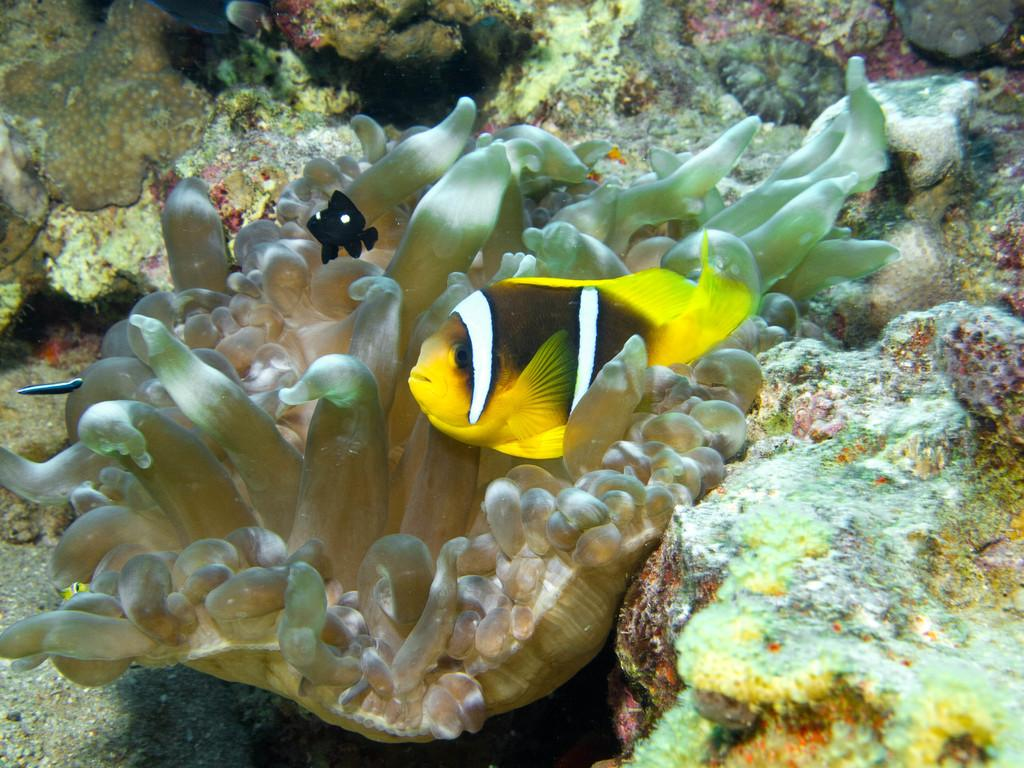What type of animal is in the image? There is a fish in the image. What color is the fish? The fish is yellow in color. Can you describe any other objects in the image? The facts provided do not mention any other objects in the image. What type of bird can be seen flying near the fish in the image? There is no bird present in the image; it only features a yellow fish. Can you tell me how many yaks are visible in the image? There are no yaks present in the image. 